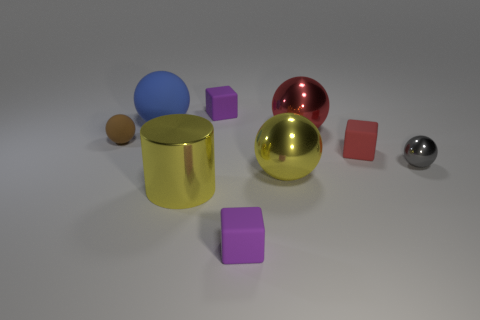Subtract all blue balls. How many balls are left? 4 Subtract 2 spheres. How many spheres are left? 3 Subtract all large yellow spheres. How many spheres are left? 4 Subtract all green spheres. Subtract all green cubes. How many spheres are left? 5 Add 1 brown spheres. How many objects exist? 10 Subtract all balls. How many objects are left? 4 Add 4 tiny brown things. How many tiny brown things are left? 5 Add 8 small yellow matte spheres. How many small yellow matte spheres exist? 8 Subtract 1 blue spheres. How many objects are left? 8 Subtract all tiny brown rubber balls. Subtract all big cylinders. How many objects are left? 7 